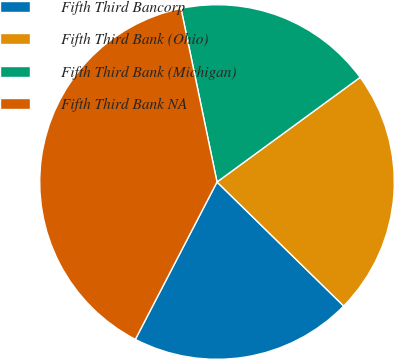Convert chart to OTSL. <chart><loc_0><loc_0><loc_500><loc_500><pie_chart><fcel>Fifth Third Bancorp<fcel>Fifth Third Bank (Ohio)<fcel>Fifth Third Bank (Michigan)<fcel>Fifth Third Bank NA<nl><fcel>20.29%<fcel>22.38%<fcel>18.21%<fcel>39.12%<nl></chart> 